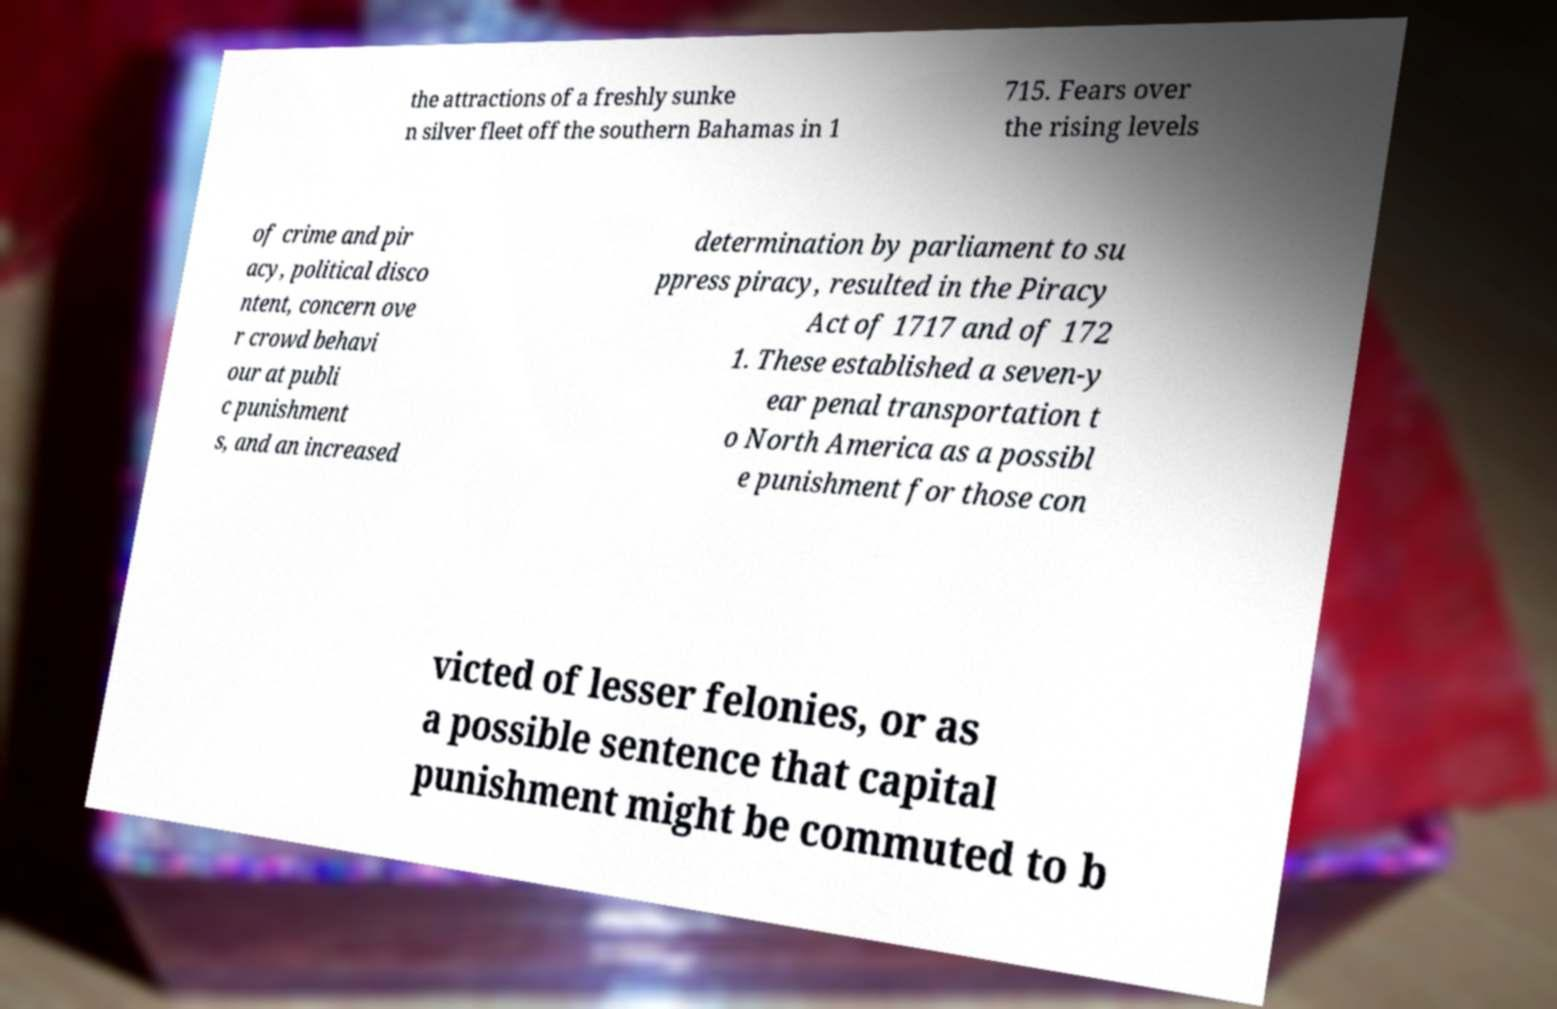I need the written content from this picture converted into text. Can you do that? the attractions of a freshly sunke n silver fleet off the southern Bahamas in 1 715. Fears over the rising levels of crime and pir acy, political disco ntent, concern ove r crowd behavi our at publi c punishment s, and an increased determination by parliament to su ppress piracy, resulted in the Piracy Act of 1717 and of 172 1. These established a seven-y ear penal transportation t o North America as a possibl e punishment for those con victed of lesser felonies, or as a possible sentence that capital punishment might be commuted to b 